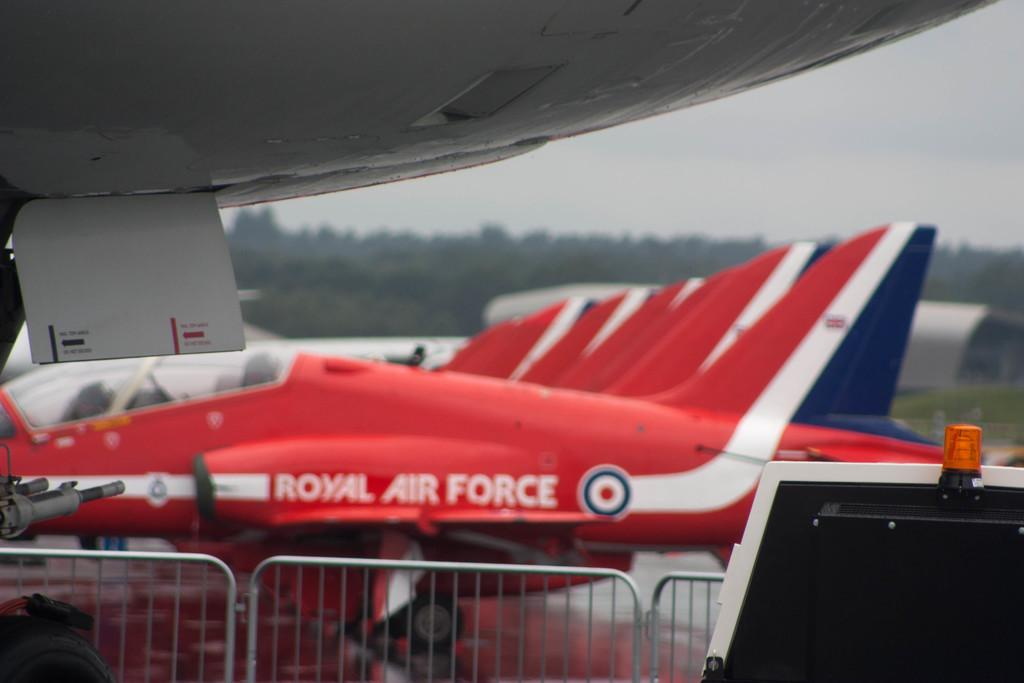<image>
Render a clear and concise summary of the photo. A red royal air force jet sits parked beside more jets of the same color. 